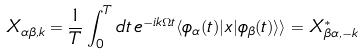<formula> <loc_0><loc_0><loc_500><loc_500>X _ { \alpha \beta , k } = \frac { 1 } { T } \int _ { 0 } ^ { T } d t \, e ^ { - i k \Omega t } \langle \phi _ { \alpha } ( t ) | x | \phi _ { \beta } ( t ) \rangle \rangle = X _ { \beta \alpha , - k } ^ { * }</formula> 